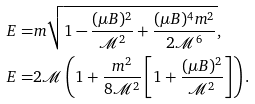<formula> <loc_0><loc_0><loc_500><loc_500>E ^ { } = & m \sqrt { 1 - \frac { ( \mu B ) ^ { 2 } } { \mathcal { M } ^ { 2 } } + \frac { ( \mu B ) ^ { 4 } m ^ { 2 } } { 2 \mathcal { M } ^ { 6 } } } , \\ E ^ { } = & 2 \mathcal { M } \left ( 1 + \frac { m ^ { 2 } } { 8 \mathcal { M } ^ { 2 } } \left [ 1 + \frac { ( \mu B ) ^ { 2 } } { \mathcal { M } ^ { 2 } } \right ] \right ) .</formula> 